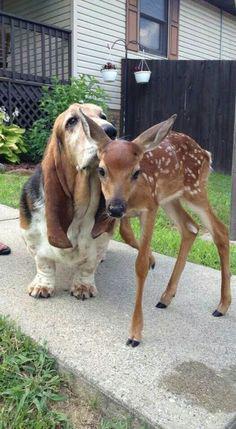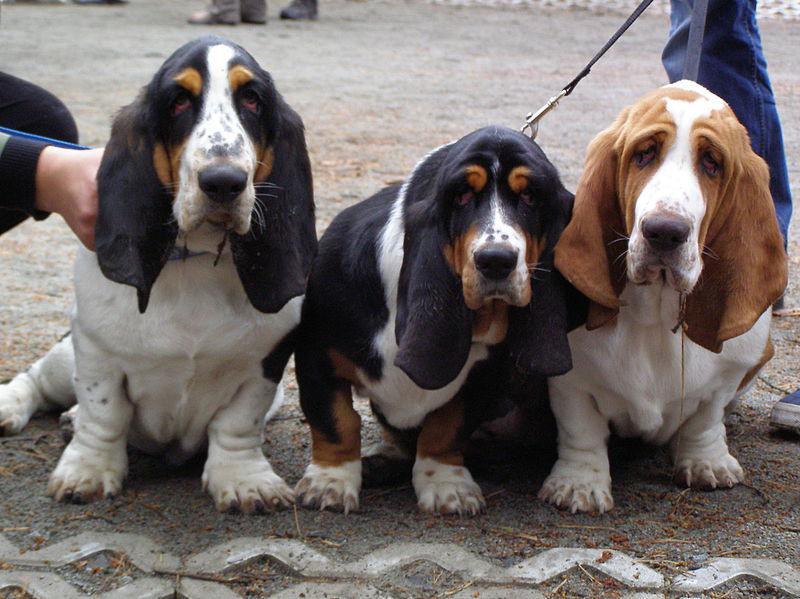The first image is the image on the left, the second image is the image on the right. Assess this claim about the two images: "One image shows a basset hound licking an animal that is not a dog.". Correct or not? Answer yes or no. Yes. The first image is the image on the left, the second image is the image on the right. For the images shown, is this caption "In one image the only animal is the basset hound, but in the second there is a basset hound with a different species." true? Answer yes or no. Yes. 